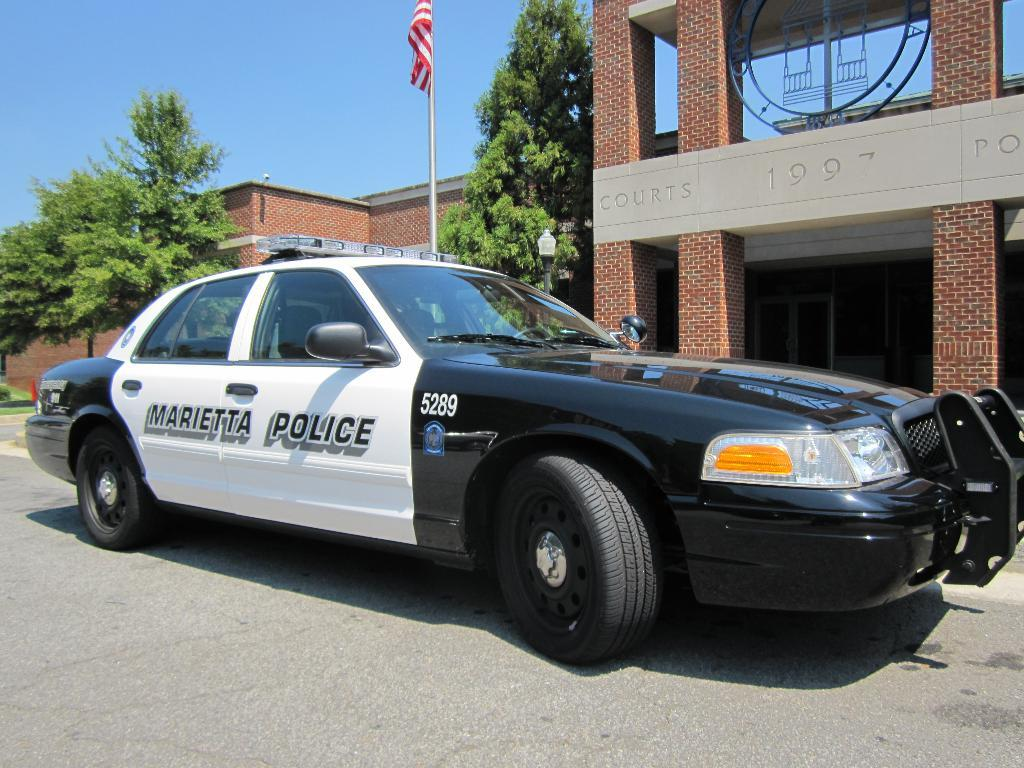<image>
Offer a succinct explanation of the picture presented. The police car probably belongs to the Marietta police department. 